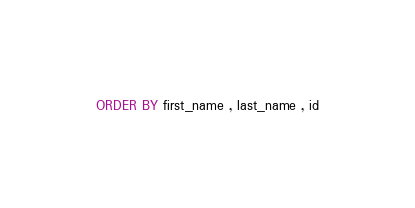Convert code to text. <code><loc_0><loc_0><loc_500><loc_500><_SQL_>ORDER BY first_name , last_name , id</code> 